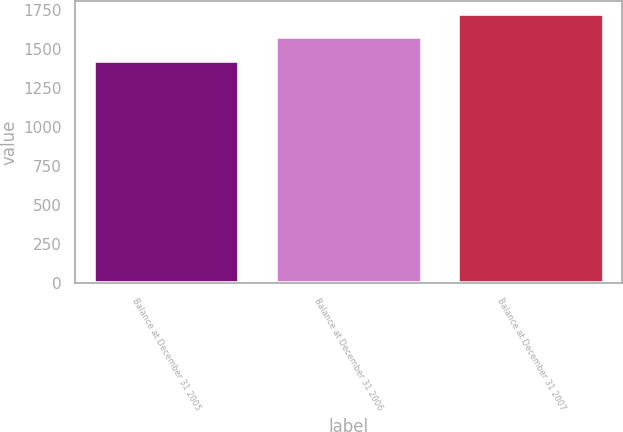Convert chart to OTSL. <chart><loc_0><loc_0><loc_500><loc_500><bar_chart><fcel>Balance at December 31 2005<fcel>Balance at December 31 2006<fcel>Balance at December 31 2007<nl><fcel>1426.2<fcel>1582.4<fcel>1726.3<nl></chart> 